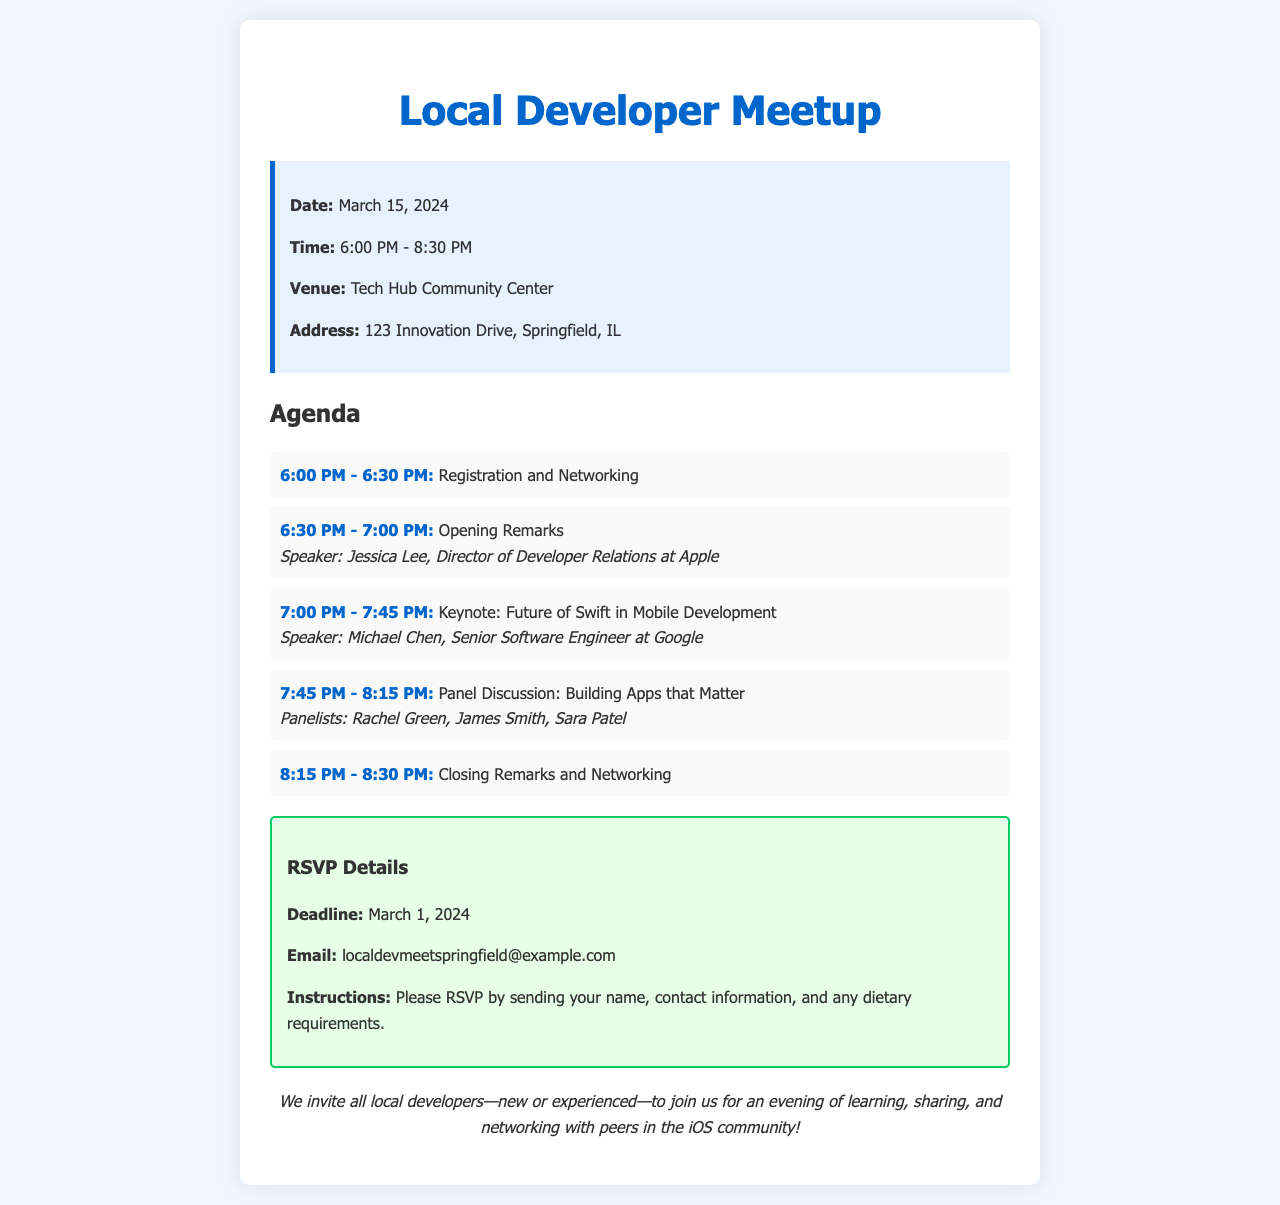What is the date of the meetup? The date of the meetup is listed in the document, which states it will occur on March 15, 2024.
Answer: March 15, 2024 What time does the meetup start? The document specifies the start time of the meetup as 6:00 PM.
Answer: 6:00 PM Who is the keynote speaker? The document identifies Michael Chen as the keynote speaker for the session on the future of Swift in mobile development.
Answer: Michael Chen What is the venue for the meetup? The document provides the venue name, which is Tech Hub Community Center.
Answer: Tech Hub Community Center What is the RSVP deadline? The RSVP deadline is mentioned in the document as March 1, 2024.
Answer: March 1, 2024 How long is the panel discussion scheduled for? The panel discussion is scheduled for 30 minutes, from 7:45 PM to 8:15 PM, as detailed in the agenda.
Answer: 30 minutes What is the main topic of the keynote session? The document states that the main topic of the keynote session is "Future of Swift in Mobile Development."
Answer: Future of Swift in Mobile Development How many agenda items are there in total? The document outlines five specific agenda items, detailing various parts of the event schedule.
Answer: Five 